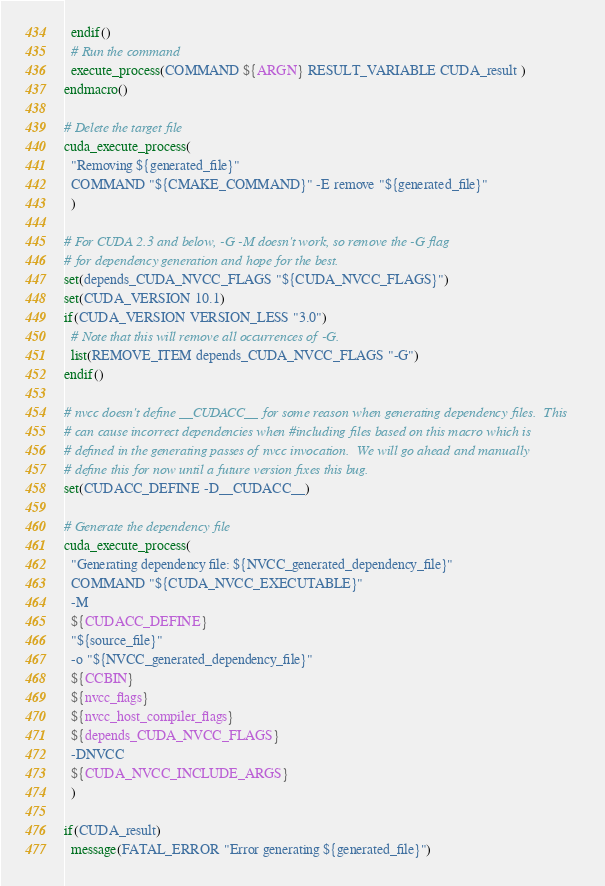Convert code to text. <code><loc_0><loc_0><loc_500><loc_500><_CMake_>  endif()
  # Run the command
  execute_process(COMMAND ${ARGN} RESULT_VARIABLE CUDA_result )
endmacro()

# Delete the target file
cuda_execute_process(
  "Removing ${generated_file}"
  COMMAND "${CMAKE_COMMAND}" -E remove "${generated_file}"
  )

# For CUDA 2.3 and below, -G -M doesn't work, so remove the -G flag
# for dependency generation and hope for the best.
set(depends_CUDA_NVCC_FLAGS "${CUDA_NVCC_FLAGS}")
set(CUDA_VERSION 10.1)
if(CUDA_VERSION VERSION_LESS "3.0")
  # Note that this will remove all occurrences of -G.
  list(REMOVE_ITEM depends_CUDA_NVCC_FLAGS "-G")
endif()

# nvcc doesn't define __CUDACC__ for some reason when generating dependency files.  This
# can cause incorrect dependencies when #including files based on this macro which is
# defined in the generating passes of nvcc invocation.  We will go ahead and manually
# define this for now until a future version fixes this bug.
set(CUDACC_DEFINE -D__CUDACC__)

# Generate the dependency file
cuda_execute_process(
  "Generating dependency file: ${NVCC_generated_dependency_file}"
  COMMAND "${CUDA_NVCC_EXECUTABLE}"
  -M
  ${CUDACC_DEFINE}
  "${source_file}"
  -o "${NVCC_generated_dependency_file}"
  ${CCBIN}
  ${nvcc_flags}
  ${nvcc_host_compiler_flags}
  ${depends_CUDA_NVCC_FLAGS}
  -DNVCC
  ${CUDA_NVCC_INCLUDE_ARGS}
  )

if(CUDA_result)
  message(FATAL_ERROR "Error generating ${generated_file}")</code> 